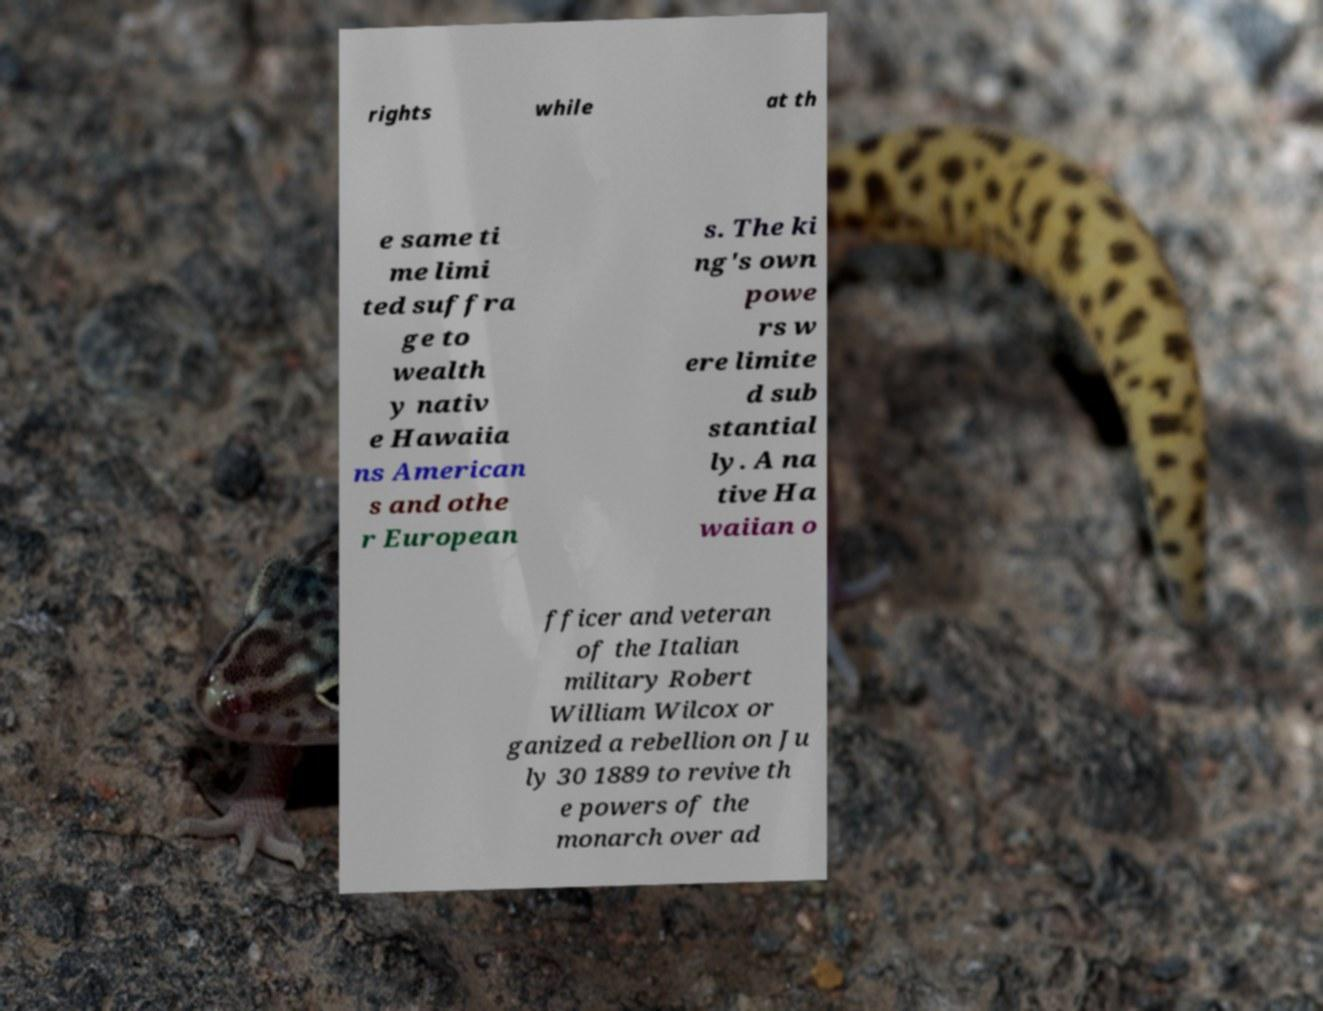Can you read and provide the text displayed in the image?This photo seems to have some interesting text. Can you extract and type it out for me? rights while at th e same ti me limi ted suffra ge to wealth y nativ e Hawaiia ns American s and othe r European s. The ki ng's own powe rs w ere limite d sub stantial ly. A na tive Ha waiian o fficer and veteran of the Italian military Robert William Wilcox or ganized a rebellion on Ju ly 30 1889 to revive th e powers of the monarch over ad 